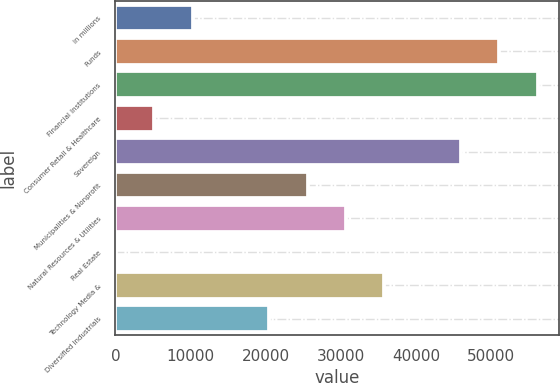Convert chart. <chart><loc_0><loc_0><loc_500><loc_500><bar_chart><fcel>in millions<fcel>Funds<fcel>Financial Institutions<fcel>Consumer Retail & Healthcare<fcel>Sovereign<fcel>Municipalities & Nonprofit<fcel>Natural Resources & Utilities<fcel>Real Estate<fcel>Technology Media &<fcel>Diversified Industrials<nl><fcel>10293<fcel>51125<fcel>56229<fcel>5189<fcel>46021<fcel>25605<fcel>30709<fcel>85<fcel>35813<fcel>20501<nl></chart> 